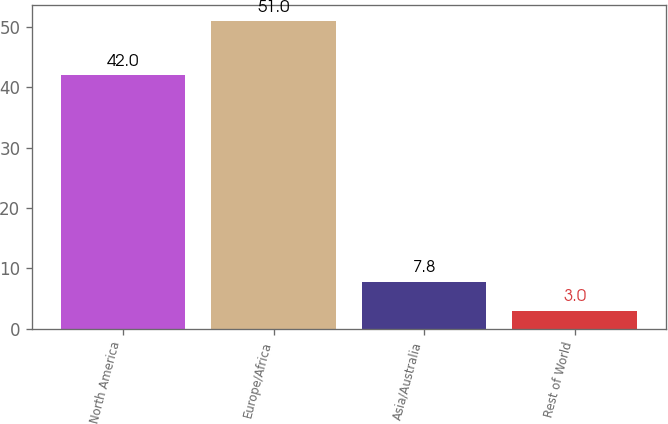Convert chart to OTSL. <chart><loc_0><loc_0><loc_500><loc_500><bar_chart><fcel>North America<fcel>Europe/Africa<fcel>Asia/Australia<fcel>Rest of World<nl><fcel>42<fcel>51<fcel>7.8<fcel>3<nl></chart> 